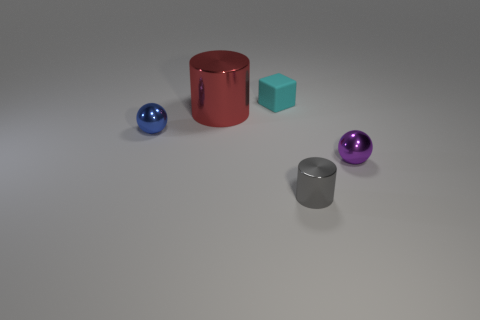Add 4 tiny cyan things. How many objects exist? 9 Subtract all cylinders. How many objects are left? 3 Subtract 0 yellow cylinders. How many objects are left? 5 Subtract all small spheres. Subtract all tiny purple shiny cylinders. How many objects are left? 3 Add 2 cubes. How many cubes are left? 3 Add 1 large gray cylinders. How many large gray cylinders exist? 1 